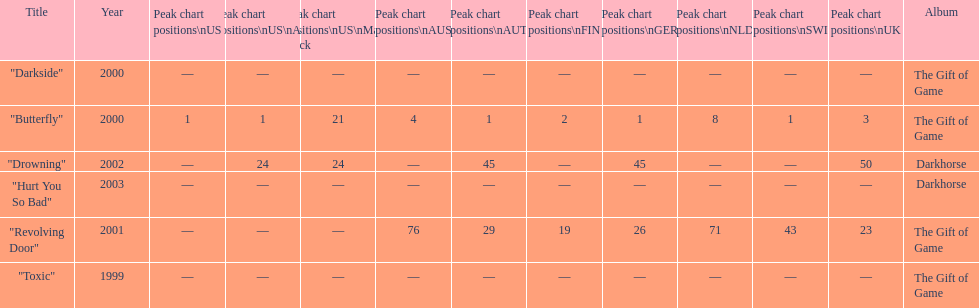How many times did the single "butterfly" rank as 1 in the chart? 5. 